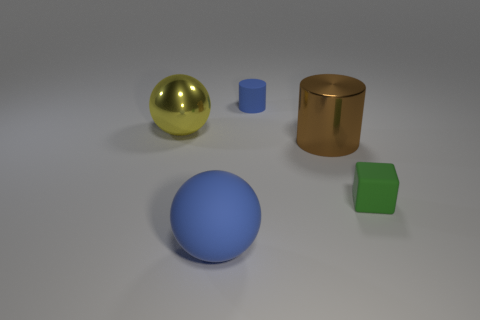Subtract all blue blocks. Subtract all blue spheres. How many blocks are left? 1 Add 2 tiny blue objects. How many objects exist? 7 Subtract all blocks. How many objects are left? 4 Subtract all big shiny things. Subtract all small blue matte cylinders. How many objects are left? 2 Add 1 large yellow spheres. How many large yellow spheres are left? 2 Add 1 large red rubber cubes. How many large red rubber cubes exist? 1 Subtract 0 gray balls. How many objects are left? 5 